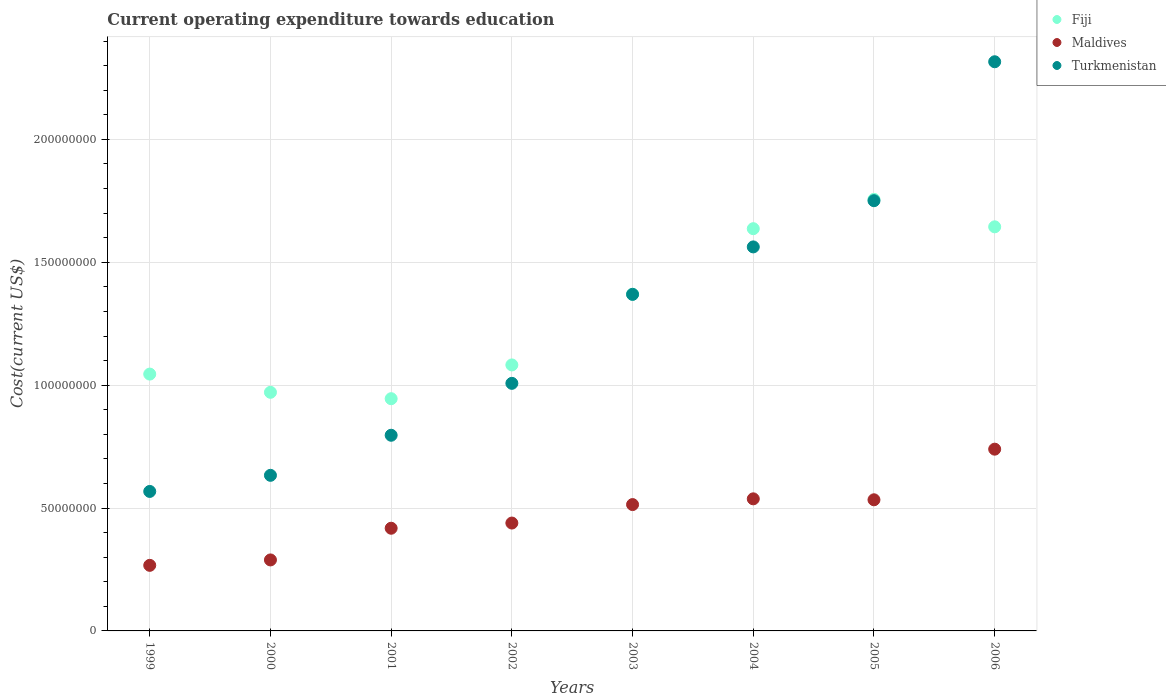How many different coloured dotlines are there?
Ensure brevity in your answer.  3. Is the number of dotlines equal to the number of legend labels?
Your answer should be compact. Yes. What is the expenditure towards education in Maldives in 2006?
Your response must be concise. 7.40e+07. Across all years, what is the maximum expenditure towards education in Turkmenistan?
Offer a terse response. 2.32e+08. Across all years, what is the minimum expenditure towards education in Fiji?
Provide a short and direct response. 9.45e+07. In which year was the expenditure towards education in Fiji minimum?
Ensure brevity in your answer.  2001. What is the total expenditure towards education in Turkmenistan in the graph?
Offer a very short reply. 1.00e+09. What is the difference between the expenditure towards education in Maldives in 1999 and that in 2006?
Give a very brief answer. -4.73e+07. What is the difference between the expenditure towards education in Turkmenistan in 2004 and the expenditure towards education in Maldives in 2000?
Provide a short and direct response. 1.27e+08. What is the average expenditure towards education in Maldives per year?
Your response must be concise. 4.67e+07. In the year 2004, what is the difference between the expenditure towards education in Maldives and expenditure towards education in Turkmenistan?
Keep it short and to the point. -1.03e+08. In how many years, is the expenditure towards education in Fiji greater than 190000000 US$?
Make the answer very short. 0. What is the ratio of the expenditure towards education in Maldives in 1999 to that in 2001?
Your answer should be compact. 0.64. Is the expenditure towards education in Maldives in 2001 less than that in 2004?
Your answer should be very brief. Yes. What is the difference between the highest and the second highest expenditure towards education in Maldives?
Make the answer very short. 2.02e+07. What is the difference between the highest and the lowest expenditure towards education in Maldives?
Give a very brief answer. 4.73e+07. Is it the case that in every year, the sum of the expenditure towards education in Maldives and expenditure towards education in Turkmenistan  is greater than the expenditure towards education in Fiji?
Your answer should be compact. No. Is the expenditure towards education in Maldives strictly greater than the expenditure towards education in Turkmenistan over the years?
Provide a short and direct response. No. Is the expenditure towards education in Turkmenistan strictly less than the expenditure towards education in Fiji over the years?
Your answer should be compact. No. How many dotlines are there?
Offer a terse response. 3. Are the values on the major ticks of Y-axis written in scientific E-notation?
Ensure brevity in your answer.  No. Does the graph contain grids?
Ensure brevity in your answer.  Yes. Where does the legend appear in the graph?
Make the answer very short. Top right. How many legend labels are there?
Keep it short and to the point. 3. How are the legend labels stacked?
Your answer should be compact. Vertical. What is the title of the graph?
Offer a terse response. Current operating expenditure towards education. Does "Puerto Rico" appear as one of the legend labels in the graph?
Ensure brevity in your answer.  No. What is the label or title of the Y-axis?
Provide a short and direct response. Cost(current US$). What is the Cost(current US$) of Fiji in 1999?
Make the answer very short. 1.05e+08. What is the Cost(current US$) in Maldives in 1999?
Provide a succinct answer. 2.67e+07. What is the Cost(current US$) in Turkmenistan in 1999?
Offer a very short reply. 5.68e+07. What is the Cost(current US$) in Fiji in 2000?
Offer a terse response. 9.71e+07. What is the Cost(current US$) in Maldives in 2000?
Keep it short and to the point. 2.89e+07. What is the Cost(current US$) in Turkmenistan in 2000?
Keep it short and to the point. 6.33e+07. What is the Cost(current US$) of Fiji in 2001?
Give a very brief answer. 9.45e+07. What is the Cost(current US$) in Maldives in 2001?
Give a very brief answer. 4.18e+07. What is the Cost(current US$) in Turkmenistan in 2001?
Make the answer very short. 7.96e+07. What is the Cost(current US$) in Fiji in 2002?
Your answer should be very brief. 1.08e+08. What is the Cost(current US$) in Maldives in 2002?
Make the answer very short. 4.39e+07. What is the Cost(current US$) in Turkmenistan in 2002?
Provide a succinct answer. 1.01e+08. What is the Cost(current US$) in Fiji in 2003?
Give a very brief answer. 1.37e+08. What is the Cost(current US$) of Maldives in 2003?
Make the answer very short. 5.14e+07. What is the Cost(current US$) of Turkmenistan in 2003?
Your answer should be compact. 1.37e+08. What is the Cost(current US$) of Fiji in 2004?
Your answer should be compact. 1.64e+08. What is the Cost(current US$) in Maldives in 2004?
Your response must be concise. 5.37e+07. What is the Cost(current US$) in Turkmenistan in 2004?
Ensure brevity in your answer.  1.56e+08. What is the Cost(current US$) in Fiji in 2005?
Offer a terse response. 1.76e+08. What is the Cost(current US$) in Maldives in 2005?
Give a very brief answer. 5.34e+07. What is the Cost(current US$) of Turkmenistan in 2005?
Offer a very short reply. 1.75e+08. What is the Cost(current US$) of Fiji in 2006?
Your answer should be compact. 1.64e+08. What is the Cost(current US$) of Maldives in 2006?
Offer a terse response. 7.40e+07. What is the Cost(current US$) in Turkmenistan in 2006?
Make the answer very short. 2.32e+08. Across all years, what is the maximum Cost(current US$) in Fiji?
Your response must be concise. 1.76e+08. Across all years, what is the maximum Cost(current US$) of Maldives?
Provide a short and direct response. 7.40e+07. Across all years, what is the maximum Cost(current US$) in Turkmenistan?
Keep it short and to the point. 2.32e+08. Across all years, what is the minimum Cost(current US$) in Fiji?
Make the answer very short. 9.45e+07. Across all years, what is the minimum Cost(current US$) of Maldives?
Make the answer very short. 2.67e+07. Across all years, what is the minimum Cost(current US$) in Turkmenistan?
Offer a terse response. 5.68e+07. What is the total Cost(current US$) of Fiji in the graph?
Give a very brief answer. 1.05e+09. What is the total Cost(current US$) of Maldives in the graph?
Offer a very short reply. 3.74e+08. What is the total Cost(current US$) of Turkmenistan in the graph?
Give a very brief answer. 1.00e+09. What is the difference between the Cost(current US$) in Fiji in 1999 and that in 2000?
Provide a succinct answer. 7.42e+06. What is the difference between the Cost(current US$) of Maldives in 1999 and that in 2000?
Provide a succinct answer. -2.20e+06. What is the difference between the Cost(current US$) of Turkmenistan in 1999 and that in 2000?
Your answer should be compact. -6.56e+06. What is the difference between the Cost(current US$) of Fiji in 1999 and that in 2001?
Make the answer very short. 1.00e+07. What is the difference between the Cost(current US$) of Maldives in 1999 and that in 2001?
Keep it short and to the point. -1.51e+07. What is the difference between the Cost(current US$) in Turkmenistan in 1999 and that in 2001?
Your answer should be compact. -2.29e+07. What is the difference between the Cost(current US$) of Fiji in 1999 and that in 2002?
Make the answer very short. -3.73e+06. What is the difference between the Cost(current US$) in Maldives in 1999 and that in 2002?
Make the answer very short. -1.72e+07. What is the difference between the Cost(current US$) in Turkmenistan in 1999 and that in 2002?
Give a very brief answer. -4.40e+07. What is the difference between the Cost(current US$) of Fiji in 1999 and that in 2003?
Your answer should be very brief. -3.25e+07. What is the difference between the Cost(current US$) of Maldives in 1999 and that in 2003?
Provide a short and direct response. -2.47e+07. What is the difference between the Cost(current US$) in Turkmenistan in 1999 and that in 2003?
Your answer should be very brief. -8.02e+07. What is the difference between the Cost(current US$) in Fiji in 1999 and that in 2004?
Your response must be concise. -5.92e+07. What is the difference between the Cost(current US$) in Maldives in 1999 and that in 2004?
Your response must be concise. -2.71e+07. What is the difference between the Cost(current US$) of Turkmenistan in 1999 and that in 2004?
Offer a very short reply. -9.95e+07. What is the difference between the Cost(current US$) in Fiji in 1999 and that in 2005?
Offer a terse response. -7.11e+07. What is the difference between the Cost(current US$) of Maldives in 1999 and that in 2005?
Your response must be concise. -2.67e+07. What is the difference between the Cost(current US$) of Turkmenistan in 1999 and that in 2005?
Offer a very short reply. -1.18e+08. What is the difference between the Cost(current US$) of Fiji in 1999 and that in 2006?
Provide a short and direct response. -5.99e+07. What is the difference between the Cost(current US$) in Maldives in 1999 and that in 2006?
Provide a succinct answer. -4.73e+07. What is the difference between the Cost(current US$) of Turkmenistan in 1999 and that in 2006?
Your response must be concise. -1.75e+08. What is the difference between the Cost(current US$) in Fiji in 2000 and that in 2001?
Your answer should be compact. 2.60e+06. What is the difference between the Cost(current US$) of Maldives in 2000 and that in 2001?
Offer a terse response. -1.29e+07. What is the difference between the Cost(current US$) in Turkmenistan in 2000 and that in 2001?
Provide a succinct answer. -1.63e+07. What is the difference between the Cost(current US$) of Fiji in 2000 and that in 2002?
Offer a very short reply. -1.11e+07. What is the difference between the Cost(current US$) of Maldives in 2000 and that in 2002?
Your response must be concise. -1.50e+07. What is the difference between the Cost(current US$) of Turkmenistan in 2000 and that in 2002?
Your answer should be compact. -3.74e+07. What is the difference between the Cost(current US$) in Fiji in 2000 and that in 2003?
Offer a very short reply. -3.99e+07. What is the difference between the Cost(current US$) of Maldives in 2000 and that in 2003?
Offer a very short reply. -2.25e+07. What is the difference between the Cost(current US$) of Turkmenistan in 2000 and that in 2003?
Your response must be concise. -7.36e+07. What is the difference between the Cost(current US$) in Fiji in 2000 and that in 2004?
Offer a terse response. -6.66e+07. What is the difference between the Cost(current US$) of Maldives in 2000 and that in 2004?
Your response must be concise. -2.49e+07. What is the difference between the Cost(current US$) of Turkmenistan in 2000 and that in 2004?
Your answer should be very brief. -9.29e+07. What is the difference between the Cost(current US$) of Fiji in 2000 and that in 2005?
Make the answer very short. -7.85e+07. What is the difference between the Cost(current US$) of Maldives in 2000 and that in 2005?
Keep it short and to the point. -2.45e+07. What is the difference between the Cost(current US$) in Turkmenistan in 2000 and that in 2005?
Ensure brevity in your answer.  -1.12e+08. What is the difference between the Cost(current US$) of Fiji in 2000 and that in 2006?
Offer a very short reply. -6.73e+07. What is the difference between the Cost(current US$) in Maldives in 2000 and that in 2006?
Offer a very short reply. -4.51e+07. What is the difference between the Cost(current US$) in Turkmenistan in 2000 and that in 2006?
Provide a short and direct response. -1.68e+08. What is the difference between the Cost(current US$) of Fiji in 2001 and that in 2002?
Ensure brevity in your answer.  -1.37e+07. What is the difference between the Cost(current US$) in Maldives in 2001 and that in 2002?
Your response must be concise. -2.11e+06. What is the difference between the Cost(current US$) of Turkmenistan in 2001 and that in 2002?
Your response must be concise. -2.11e+07. What is the difference between the Cost(current US$) in Fiji in 2001 and that in 2003?
Ensure brevity in your answer.  -4.25e+07. What is the difference between the Cost(current US$) in Maldives in 2001 and that in 2003?
Your answer should be very brief. -9.63e+06. What is the difference between the Cost(current US$) in Turkmenistan in 2001 and that in 2003?
Provide a short and direct response. -5.73e+07. What is the difference between the Cost(current US$) of Fiji in 2001 and that in 2004?
Your response must be concise. -6.92e+07. What is the difference between the Cost(current US$) of Maldives in 2001 and that in 2004?
Your answer should be compact. -1.20e+07. What is the difference between the Cost(current US$) of Turkmenistan in 2001 and that in 2004?
Your answer should be very brief. -7.66e+07. What is the difference between the Cost(current US$) in Fiji in 2001 and that in 2005?
Keep it short and to the point. -8.11e+07. What is the difference between the Cost(current US$) of Maldives in 2001 and that in 2005?
Offer a very short reply. -1.16e+07. What is the difference between the Cost(current US$) in Turkmenistan in 2001 and that in 2005?
Your answer should be compact. -9.54e+07. What is the difference between the Cost(current US$) in Fiji in 2001 and that in 2006?
Your response must be concise. -6.99e+07. What is the difference between the Cost(current US$) of Maldives in 2001 and that in 2006?
Your response must be concise. -3.22e+07. What is the difference between the Cost(current US$) of Turkmenistan in 2001 and that in 2006?
Give a very brief answer. -1.52e+08. What is the difference between the Cost(current US$) in Fiji in 2002 and that in 2003?
Your response must be concise. -2.88e+07. What is the difference between the Cost(current US$) in Maldives in 2002 and that in 2003?
Ensure brevity in your answer.  -7.51e+06. What is the difference between the Cost(current US$) in Turkmenistan in 2002 and that in 2003?
Make the answer very short. -3.62e+07. What is the difference between the Cost(current US$) of Fiji in 2002 and that in 2004?
Offer a terse response. -5.54e+07. What is the difference between the Cost(current US$) in Maldives in 2002 and that in 2004?
Your response must be concise. -9.85e+06. What is the difference between the Cost(current US$) in Turkmenistan in 2002 and that in 2004?
Make the answer very short. -5.55e+07. What is the difference between the Cost(current US$) in Fiji in 2002 and that in 2005?
Give a very brief answer. -6.74e+07. What is the difference between the Cost(current US$) of Maldives in 2002 and that in 2005?
Your answer should be very brief. -9.46e+06. What is the difference between the Cost(current US$) of Turkmenistan in 2002 and that in 2005?
Your answer should be very brief. -7.43e+07. What is the difference between the Cost(current US$) in Fiji in 2002 and that in 2006?
Keep it short and to the point. -5.62e+07. What is the difference between the Cost(current US$) of Maldives in 2002 and that in 2006?
Your answer should be very brief. -3.01e+07. What is the difference between the Cost(current US$) of Turkmenistan in 2002 and that in 2006?
Your answer should be very brief. -1.31e+08. What is the difference between the Cost(current US$) of Fiji in 2003 and that in 2004?
Your answer should be compact. -2.67e+07. What is the difference between the Cost(current US$) of Maldives in 2003 and that in 2004?
Give a very brief answer. -2.34e+06. What is the difference between the Cost(current US$) of Turkmenistan in 2003 and that in 2004?
Give a very brief answer. -1.93e+07. What is the difference between the Cost(current US$) of Fiji in 2003 and that in 2005?
Provide a succinct answer. -3.86e+07. What is the difference between the Cost(current US$) of Maldives in 2003 and that in 2005?
Make the answer very short. -1.95e+06. What is the difference between the Cost(current US$) in Turkmenistan in 2003 and that in 2005?
Your answer should be compact. -3.81e+07. What is the difference between the Cost(current US$) in Fiji in 2003 and that in 2006?
Provide a short and direct response. -2.74e+07. What is the difference between the Cost(current US$) in Maldives in 2003 and that in 2006?
Your answer should be compact. -2.25e+07. What is the difference between the Cost(current US$) in Turkmenistan in 2003 and that in 2006?
Give a very brief answer. -9.46e+07. What is the difference between the Cost(current US$) in Fiji in 2004 and that in 2005?
Your answer should be compact. -1.19e+07. What is the difference between the Cost(current US$) in Maldives in 2004 and that in 2005?
Make the answer very short. 3.88e+05. What is the difference between the Cost(current US$) of Turkmenistan in 2004 and that in 2005?
Your answer should be compact. -1.88e+07. What is the difference between the Cost(current US$) of Fiji in 2004 and that in 2006?
Give a very brief answer. -7.61e+05. What is the difference between the Cost(current US$) in Maldives in 2004 and that in 2006?
Ensure brevity in your answer.  -2.02e+07. What is the difference between the Cost(current US$) of Turkmenistan in 2004 and that in 2006?
Your answer should be very brief. -7.53e+07. What is the difference between the Cost(current US$) in Fiji in 2005 and that in 2006?
Offer a very short reply. 1.12e+07. What is the difference between the Cost(current US$) in Maldives in 2005 and that in 2006?
Provide a short and direct response. -2.06e+07. What is the difference between the Cost(current US$) in Turkmenistan in 2005 and that in 2006?
Provide a short and direct response. -5.65e+07. What is the difference between the Cost(current US$) in Fiji in 1999 and the Cost(current US$) in Maldives in 2000?
Provide a succinct answer. 7.56e+07. What is the difference between the Cost(current US$) of Fiji in 1999 and the Cost(current US$) of Turkmenistan in 2000?
Provide a short and direct response. 4.12e+07. What is the difference between the Cost(current US$) in Maldives in 1999 and the Cost(current US$) in Turkmenistan in 2000?
Offer a very short reply. -3.66e+07. What is the difference between the Cost(current US$) in Fiji in 1999 and the Cost(current US$) in Maldives in 2001?
Keep it short and to the point. 6.27e+07. What is the difference between the Cost(current US$) in Fiji in 1999 and the Cost(current US$) in Turkmenistan in 2001?
Make the answer very short. 2.49e+07. What is the difference between the Cost(current US$) in Maldives in 1999 and the Cost(current US$) in Turkmenistan in 2001?
Make the answer very short. -5.29e+07. What is the difference between the Cost(current US$) in Fiji in 1999 and the Cost(current US$) in Maldives in 2002?
Provide a succinct answer. 6.06e+07. What is the difference between the Cost(current US$) in Fiji in 1999 and the Cost(current US$) in Turkmenistan in 2002?
Provide a succinct answer. 3.77e+06. What is the difference between the Cost(current US$) of Maldives in 1999 and the Cost(current US$) of Turkmenistan in 2002?
Offer a very short reply. -7.41e+07. What is the difference between the Cost(current US$) in Fiji in 1999 and the Cost(current US$) in Maldives in 2003?
Provide a succinct answer. 5.31e+07. What is the difference between the Cost(current US$) in Fiji in 1999 and the Cost(current US$) in Turkmenistan in 2003?
Offer a very short reply. -3.24e+07. What is the difference between the Cost(current US$) in Maldives in 1999 and the Cost(current US$) in Turkmenistan in 2003?
Your answer should be compact. -1.10e+08. What is the difference between the Cost(current US$) in Fiji in 1999 and the Cost(current US$) in Maldives in 2004?
Make the answer very short. 5.08e+07. What is the difference between the Cost(current US$) in Fiji in 1999 and the Cost(current US$) in Turkmenistan in 2004?
Your answer should be compact. -5.17e+07. What is the difference between the Cost(current US$) of Maldives in 1999 and the Cost(current US$) of Turkmenistan in 2004?
Make the answer very short. -1.30e+08. What is the difference between the Cost(current US$) of Fiji in 1999 and the Cost(current US$) of Maldives in 2005?
Provide a succinct answer. 5.11e+07. What is the difference between the Cost(current US$) of Fiji in 1999 and the Cost(current US$) of Turkmenistan in 2005?
Keep it short and to the point. -7.06e+07. What is the difference between the Cost(current US$) in Maldives in 1999 and the Cost(current US$) in Turkmenistan in 2005?
Ensure brevity in your answer.  -1.48e+08. What is the difference between the Cost(current US$) in Fiji in 1999 and the Cost(current US$) in Maldives in 2006?
Your answer should be compact. 3.06e+07. What is the difference between the Cost(current US$) of Fiji in 1999 and the Cost(current US$) of Turkmenistan in 2006?
Keep it short and to the point. -1.27e+08. What is the difference between the Cost(current US$) in Maldives in 1999 and the Cost(current US$) in Turkmenistan in 2006?
Give a very brief answer. -2.05e+08. What is the difference between the Cost(current US$) in Fiji in 2000 and the Cost(current US$) in Maldives in 2001?
Offer a very short reply. 5.53e+07. What is the difference between the Cost(current US$) of Fiji in 2000 and the Cost(current US$) of Turkmenistan in 2001?
Provide a short and direct response. 1.75e+07. What is the difference between the Cost(current US$) of Maldives in 2000 and the Cost(current US$) of Turkmenistan in 2001?
Provide a short and direct response. -5.07e+07. What is the difference between the Cost(current US$) of Fiji in 2000 and the Cost(current US$) of Maldives in 2002?
Give a very brief answer. 5.32e+07. What is the difference between the Cost(current US$) in Fiji in 2000 and the Cost(current US$) in Turkmenistan in 2002?
Offer a very short reply. -3.65e+06. What is the difference between the Cost(current US$) of Maldives in 2000 and the Cost(current US$) of Turkmenistan in 2002?
Your answer should be very brief. -7.19e+07. What is the difference between the Cost(current US$) in Fiji in 2000 and the Cost(current US$) in Maldives in 2003?
Make the answer very short. 4.57e+07. What is the difference between the Cost(current US$) of Fiji in 2000 and the Cost(current US$) of Turkmenistan in 2003?
Provide a short and direct response. -3.99e+07. What is the difference between the Cost(current US$) in Maldives in 2000 and the Cost(current US$) in Turkmenistan in 2003?
Offer a very short reply. -1.08e+08. What is the difference between the Cost(current US$) in Fiji in 2000 and the Cost(current US$) in Maldives in 2004?
Give a very brief answer. 4.33e+07. What is the difference between the Cost(current US$) of Fiji in 2000 and the Cost(current US$) of Turkmenistan in 2004?
Offer a terse response. -5.92e+07. What is the difference between the Cost(current US$) of Maldives in 2000 and the Cost(current US$) of Turkmenistan in 2004?
Offer a very short reply. -1.27e+08. What is the difference between the Cost(current US$) in Fiji in 2000 and the Cost(current US$) in Maldives in 2005?
Your answer should be very brief. 4.37e+07. What is the difference between the Cost(current US$) of Fiji in 2000 and the Cost(current US$) of Turkmenistan in 2005?
Your answer should be compact. -7.80e+07. What is the difference between the Cost(current US$) in Maldives in 2000 and the Cost(current US$) in Turkmenistan in 2005?
Give a very brief answer. -1.46e+08. What is the difference between the Cost(current US$) of Fiji in 2000 and the Cost(current US$) of Maldives in 2006?
Give a very brief answer. 2.31e+07. What is the difference between the Cost(current US$) in Fiji in 2000 and the Cost(current US$) in Turkmenistan in 2006?
Your answer should be very brief. -1.35e+08. What is the difference between the Cost(current US$) in Maldives in 2000 and the Cost(current US$) in Turkmenistan in 2006?
Provide a short and direct response. -2.03e+08. What is the difference between the Cost(current US$) in Fiji in 2001 and the Cost(current US$) in Maldives in 2002?
Keep it short and to the point. 5.06e+07. What is the difference between the Cost(current US$) of Fiji in 2001 and the Cost(current US$) of Turkmenistan in 2002?
Make the answer very short. -6.25e+06. What is the difference between the Cost(current US$) in Maldives in 2001 and the Cost(current US$) in Turkmenistan in 2002?
Provide a succinct answer. -5.90e+07. What is the difference between the Cost(current US$) of Fiji in 2001 and the Cost(current US$) of Maldives in 2003?
Offer a terse response. 4.31e+07. What is the difference between the Cost(current US$) in Fiji in 2001 and the Cost(current US$) in Turkmenistan in 2003?
Provide a succinct answer. -4.25e+07. What is the difference between the Cost(current US$) of Maldives in 2001 and the Cost(current US$) of Turkmenistan in 2003?
Offer a very short reply. -9.52e+07. What is the difference between the Cost(current US$) of Fiji in 2001 and the Cost(current US$) of Maldives in 2004?
Ensure brevity in your answer.  4.07e+07. What is the difference between the Cost(current US$) in Fiji in 2001 and the Cost(current US$) in Turkmenistan in 2004?
Offer a very short reply. -6.18e+07. What is the difference between the Cost(current US$) in Maldives in 2001 and the Cost(current US$) in Turkmenistan in 2004?
Offer a terse response. -1.14e+08. What is the difference between the Cost(current US$) in Fiji in 2001 and the Cost(current US$) in Maldives in 2005?
Keep it short and to the point. 4.11e+07. What is the difference between the Cost(current US$) of Fiji in 2001 and the Cost(current US$) of Turkmenistan in 2005?
Ensure brevity in your answer.  -8.06e+07. What is the difference between the Cost(current US$) in Maldives in 2001 and the Cost(current US$) in Turkmenistan in 2005?
Ensure brevity in your answer.  -1.33e+08. What is the difference between the Cost(current US$) in Fiji in 2001 and the Cost(current US$) in Maldives in 2006?
Your response must be concise. 2.05e+07. What is the difference between the Cost(current US$) of Fiji in 2001 and the Cost(current US$) of Turkmenistan in 2006?
Provide a succinct answer. -1.37e+08. What is the difference between the Cost(current US$) in Maldives in 2001 and the Cost(current US$) in Turkmenistan in 2006?
Offer a terse response. -1.90e+08. What is the difference between the Cost(current US$) of Fiji in 2002 and the Cost(current US$) of Maldives in 2003?
Your answer should be compact. 5.68e+07. What is the difference between the Cost(current US$) in Fiji in 2002 and the Cost(current US$) in Turkmenistan in 2003?
Make the answer very short. -2.87e+07. What is the difference between the Cost(current US$) in Maldives in 2002 and the Cost(current US$) in Turkmenistan in 2003?
Make the answer very short. -9.30e+07. What is the difference between the Cost(current US$) of Fiji in 2002 and the Cost(current US$) of Maldives in 2004?
Keep it short and to the point. 5.45e+07. What is the difference between the Cost(current US$) of Fiji in 2002 and the Cost(current US$) of Turkmenistan in 2004?
Give a very brief answer. -4.80e+07. What is the difference between the Cost(current US$) of Maldives in 2002 and the Cost(current US$) of Turkmenistan in 2004?
Provide a succinct answer. -1.12e+08. What is the difference between the Cost(current US$) of Fiji in 2002 and the Cost(current US$) of Maldives in 2005?
Offer a terse response. 5.49e+07. What is the difference between the Cost(current US$) of Fiji in 2002 and the Cost(current US$) of Turkmenistan in 2005?
Ensure brevity in your answer.  -6.68e+07. What is the difference between the Cost(current US$) of Maldives in 2002 and the Cost(current US$) of Turkmenistan in 2005?
Keep it short and to the point. -1.31e+08. What is the difference between the Cost(current US$) in Fiji in 2002 and the Cost(current US$) in Maldives in 2006?
Offer a very short reply. 3.43e+07. What is the difference between the Cost(current US$) in Fiji in 2002 and the Cost(current US$) in Turkmenistan in 2006?
Your response must be concise. -1.23e+08. What is the difference between the Cost(current US$) in Maldives in 2002 and the Cost(current US$) in Turkmenistan in 2006?
Provide a short and direct response. -1.88e+08. What is the difference between the Cost(current US$) of Fiji in 2003 and the Cost(current US$) of Maldives in 2004?
Provide a short and direct response. 8.33e+07. What is the difference between the Cost(current US$) in Fiji in 2003 and the Cost(current US$) in Turkmenistan in 2004?
Give a very brief answer. -1.92e+07. What is the difference between the Cost(current US$) of Maldives in 2003 and the Cost(current US$) of Turkmenistan in 2004?
Offer a terse response. -1.05e+08. What is the difference between the Cost(current US$) in Fiji in 2003 and the Cost(current US$) in Maldives in 2005?
Make the answer very short. 8.37e+07. What is the difference between the Cost(current US$) in Fiji in 2003 and the Cost(current US$) in Turkmenistan in 2005?
Offer a terse response. -3.80e+07. What is the difference between the Cost(current US$) of Maldives in 2003 and the Cost(current US$) of Turkmenistan in 2005?
Provide a short and direct response. -1.24e+08. What is the difference between the Cost(current US$) in Fiji in 2003 and the Cost(current US$) in Maldives in 2006?
Provide a short and direct response. 6.31e+07. What is the difference between the Cost(current US$) of Fiji in 2003 and the Cost(current US$) of Turkmenistan in 2006?
Ensure brevity in your answer.  -9.46e+07. What is the difference between the Cost(current US$) in Maldives in 2003 and the Cost(current US$) in Turkmenistan in 2006?
Your answer should be very brief. -1.80e+08. What is the difference between the Cost(current US$) in Fiji in 2004 and the Cost(current US$) in Maldives in 2005?
Keep it short and to the point. 1.10e+08. What is the difference between the Cost(current US$) in Fiji in 2004 and the Cost(current US$) in Turkmenistan in 2005?
Give a very brief answer. -1.14e+07. What is the difference between the Cost(current US$) in Maldives in 2004 and the Cost(current US$) in Turkmenistan in 2005?
Provide a succinct answer. -1.21e+08. What is the difference between the Cost(current US$) in Fiji in 2004 and the Cost(current US$) in Maldives in 2006?
Provide a succinct answer. 8.97e+07. What is the difference between the Cost(current US$) in Fiji in 2004 and the Cost(current US$) in Turkmenistan in 2006?
Make the answer very short. -6.79e+07. What is the difference between the Cost(current US$) of Maldives in 2004 and the Cost(current US$) of Turkmenistan in 2006?
Your answer should be very brief. -1.78e+08. What is the difference between the Cost(current US$) of Fiji in 2005 and the Cost(current US$) of Maldives in 2006?
Provide a succinct answer. 1.02e+08. What is the difference between the Cost(current US$) of Fiji in 2005 and the Cost(current US$) of Turkmenistan in 2006?
Provide a succinct answer. -5.60e+07. What is the difference between the Cost(current US$) of Maldives in 2005 and the Cost(current US$) of Turkmenistan in 2006?
Your answer should be compact. -1.78e+08. What is the average Cost(current US$) of Fiji per year?
Offer a terse response. 1.31e+08. What is the average Cost(current US$) in Maldives per year?
Provide a succinct answer. 4.67e+07. What is the average Cost(current US$) of Turkmenistan per year?
Offer a very short reply. 1.25e+08. In the year 1999, what is the difference between the Cost(current US$) in Fiji and Cost(current US$) in Maldives?
Make the answer very short. 7.78e+07. In the year 1999, what is the difference between the Cost(current US$) of Fiji and Cost(current US$) of Turkmenistan?
Provide a succinct answer. 4.78e+07. In the year 1999, what is the difference between the Cost(current US$) in Maldives and Cost(current US$) in Turkmenistan?
Give a very brief answer. -3.01e+07. In the year 2000, what is the difference between the Cost(current US$) of Fiji and Cost(current US$) of Maldives?
Offer a terse response. 6.82e+07. In the year 2000, what is the difference between the Cost(current US$) in Fiji and Cost(current US$) in Turkmenistan?
Offer a very short reply. 3.38e+07. In the year 2000, what is the difference between the Cost(current US$) in Maldives and Cost(current US$) in Turkmenistan?
Offer a terse response. -3.44e+07. In the year 2001, what is the difference between the Cost(current US$) of Fiji and Cost(current US$) of Maldives?
Provide a short and direct response. 5.27e+07. In the year 2001, what is the difference between the Cost(current US$) in Fiji and Cost(current US$) in Turkmenistan?
Make the answer very short. 1.49e+07. In the year 2001, what is the difference between the Cost(current US$) in Maldives and Cost(current US$) in Turkmenistan?
Offer a terse response. -3.78e+07. In the year 2002, what is the difference between the Cost(current US$) in Fiji and Cost(current US$) in Maldives?
Provide a succinct answer. 6.43e+07. In the year 2002, what is the difference between the Cost(current US$) in Fiji and Cost(current US$) in Turkmenistan?
Provide a succinct answer. 7.49e+06. In the year 2002, what is the difference between the Cost(current US$) in Maldives and Cost(current US$) in Turkmenistan?
Provide a succinct answer. -5.68e+07. In the year 2003, what is the difference between the Cost(current US$) of Fiji and Cost(current US$) of Maldives?
Ensure brevity in your answer.  8.56e+07. In the year 2003, what is the difference between the Cost(current US$) in Fiji and Cost(current US$) in Turkmenistan?
Provide a short and direct response. 6.57e+04. In the year 2003, what is the difference between the Cost(current US$) in Maldives and Cost(current US$) in Turkmenistan?
Offer a very short reply. -8.55e+07. In the year 2004, what is the difference between the Cost(current US$) in Fiji and Cost(current US$) in Maldives?
Your answer should be compact. 1.10e+08. In the year 2004, what is the difference between the Cost(current US$) in Fiji and Cost(current US$) in Turkmenistan?
Make the answer very short. 7.41e+06. In the year 2004, what is the difference between the Cost(current US$) in Maldives and Cost(current US$) in Turkmenistan?
Your answer should be compact. -1.03e+08. In the year 2005, what is the difference between the Cost(current US$) in Fiji and Cost(current US$) in Maldives?
Make the answer very short. 1.22e+08. In the year 2005, what is the difference between the Cost(current US$) of Fiji and Cost(current US$) of Turkmenistan?
Make the answer very short. 5.44e+05. In the year 2005, what is the difference between the Cost(current US$) in Maldives and Cost(current US$) in Turkmenistan?
Keep it short and to the point. -1.22e+08. In the year 2006, what is the difference between the Cost(current US$) in Fiji and Cost(current US$) in Maldives?
Give a very brief answer. 9.05e+07. In the year 2006, what is the difference between the Cost(current US$) of Fiji and Cost(current US$) of Turkmenistan?
Your answer should be compact. -6.72e+07. In the year 2006, what is the difference between the Cost(current US$) of Maldives and Cost(current US$) of Turkmenistan?
Your response must be concise. -1.58e+08. What is the ratio of the Cost(current US$) of Fiji in 1999 to that in 2000?
Provide a short and direct response. 1.08. What is the ratio of the Cost(current US$) of Maldives in 1999 to that in 2000?
Provide a succinct answer. 0.92. What is the ratio of the Cost(current US$) in Turkmenistan in 1999 to that in 2000?
Your answer should be very brief. 0.9. What is the ratio of the Cost(current US$) in Fiji in 1999 to that in 2001?
Offer a terse response. 1.11. What is the ratio of the Cost(current US$) of Maldives in 1999 to that in 2001?
Your answer should be compact. 0.64. What is the ratio of the Cost(current US$) in Turkmenistan in 1999 to that in 2001?
Keep it short and to the point. 0.71. What is the ratio of the Cost(current US$) in Fiji in 1999 to that in 2002?
Offer a very short reply. 0.97. What is the ratio of the Cost(current US$) in Maldives in 1999 to that in 2002?
Offer a very short reply. 0.61. What is the ratio of the Cost(current US$) in Turkmenistan in 1999 to that in 2002?
Your response must be concise. 0.56. What is the ratio of the Cost(current US$) in Fiji in 1999 to that in 2003?
Your response must be concise. 0.76. What is the ratio of the Cost(current US$) in Maldives in 1999 to that in 2003?
Your response must be concise. 0.52. What is the ratio of the Cost(current US$) of Turkmenistan in 1999 to that in 2003?
Your answer should be compact. 0.41. What is the ratio of the Cost(current US$) of Fiji in 1999 to that in 2004?
Keep it short and to the point. 0.64. What is the ratio of the Cost(current US$) of Maldives in 1999 to that in 2004?
Offer a terse response. 0.5. What is the ratio of the Cost(current US$) of Turkmenistan in 1999 to that in 2004?
Keep it short and to the point. 0.36. What is the ratio of the Cost(current US$) of Fiji in 1999 to that in 2005?
Provide a succinct answer. 0.6. What is the ratio of the Cost(current US$) of Maldives in 1999 to that in 2005?
Your answer should be very brief. 0.5. What is the ratio of the Cost(current US$) in Turkmenistan in 1999 to that in 2005?
Offer a terse response. 0.32. What is the ratio of the Cost(current US$) in Fiji in 1999 to that in 2006?
Ensure brevity in your answer.  0.64. What is the ratio of the Cost(current US$) in Maldives in 1999 to that in 2006?
Ensure brevity in your answer.  0.36. What is the ratio of the Cost(current US$) in Turkmenistan in 1999 to that in 2006?
Your answer should be compact. 0.25. What is the ratio of the Cost(current US$) in Fiji in 2000 to that in 2001?
Your response must be concise. 1.03. What is the ratio of the Cost(current US$) of Maldives in 2000 to that in 2001?
Your answer should be very brief. 0.69. What is the ratio of the Cost(current US$) of Turkmenistan in 2000 to that in 2001?
Offer a very short reply. 0.8. What is the ratio of the Cost(current US$) of Fiji in 2000 to that in 2002?
Offer a very short reply. 0.9. What is the ratio of the Cost(current US$) in Maldives in 2000 to that in 2002?
Give a very brief answer. 0.66. What is the ratio of the Cost(current US$) in Turkmenistan in 2000 to that in 2002?
Your response must be concise. 0.63. What is the ratio of the Cost(current US$) of Fiji in 2000 to that in 2003?
Give a very brief answer. 0.71. What is the ratio of the Cost(current US$) of Maldives in 2000 to that in 2003?
Your answer should be compact. 0.56. What is the ratio of the Cost(current US$) in Turkmenistan in 2000 to that in 2003?
Make the answer very short. 0.46. What is the ratio of the Cost(current US$) in Fiji in 2000 to that in 2004?
Give a very brief answer. 0.59. What is the ratio of the Cost(current US$) in Maldives in 2000 to that in 2004?
Offer a terse response. 0.54. What is the ratio of the Cost(current US$) in Turkmenistan in 2000 to that in 2004?
Your answer should be very brief. 0.41. What is the ratio of the Cost(current US$) of Fiji in 2000 to that in 2005?
Your answer should be compact. 0.55. What is the ratio of the Cost(current US$) in Maldives in 2000 to that in 2005?
Ensure brevity in your answer.  0.54. What is the ratio of the Cost(current US$) of Turkmenistan in 2000 to that in 2005?
Your answer should be compact. 0.36. What is the ratio of the Cost(current US$) of Fiji in 2000 to that in 2006?
Your response must be concise. 0.59. What is the ratio of the Cost(current US$) in Maldives in 2000 to that in 2006?
Provide a succinct answer. 0.39. What is the ratio of the Cost(current US$) in Turkmenistan in 2000 to that in 2006?
Your answer should be compact. 0.27. What is the ratio of the Cost(current US$) of Fiji in 2001 to that in 2002?
Provide a succinct answer. 0.87. What is the ratio of the Cost(current US$) of Maldives in 2001 to that in 2002?
Offer a terse response. 0.95. What is the ratio of the Cost(current US$) of Turkmenistan in 2001 to that in 2002?
Your answer should be very brief. 0.79. What is the ratio of the Cost(current US$) in Fiji in 2001 to that in 2003?
Ensure brevity in your answer.  0.69. What is the ratio of the Cost(current US$) of Maldives in 2001 to that in 2003?
Offer a very short reply. 0.81. What is the ratio of the Cost(current US$) of Turkmenistan in 2001 to that in 2003?
Give a very brief answer. 0.58. What is the ratio of the Cost(current US$) in Fiji in 2001 to that in 2004?
Make the answer very short. 0.58. What is the ratio of the Cost(current US$) of Maldives in 2001 to that in 2004?
Your answer should be very brief. 0.78. What is the ratio of the Cost(current US$) in Turkmenistan in 2001 to that in 2004?
Your response must be concise. 0.51. What is the ratio of the Cost(current US$) in Fiji in 2001 to that in 2005?
Make the answer very short. 0.54. What is the ratio of the Cost(current US$) in Maldives in 2001 to that in 2005?
Your answer should be very brief. 0.78. What is the ratio of the Cost(current US$) of Turkmenistan in 2001 to that in 2005?
Provide a succinct answer. 0.45. What is the ratio of the Cost(current US$) of Fiji in 2001 to that in 2006?
Keep it short and to the point. 0.57. What is the ratio of the Cost(current US$) of Maldives in 2001 to that in 2006?
Ensure brevity in your answer.  0.56. What is the ratio of the Cost(current US$) of Turkmenistan in 2001 to that in 2006?
Offer a very short reply. 0.34. What is the ratio of the Cost(current US$) of Fiji in 2002 to that in 2003?
Your answer should be very brief. 0.79. What is the ratio of the Cost(current US$) in Maldives in 2002 to that in 2003?
Offer a very short reply. 0.85. What is the ratio of the Cost(current US$) of Turkmenistan in 2002 to that in 2003?
Your answer should be compact. 0.74. What is the ratio of the Cost(current US$) in Fiji in 2002 to that in 2004?
Keep it short and to the point. 0.66. What is the ratio of the Cost(current US$) of Maldives in 2002 to that in 2004?
Give a very brief answer. 0.82. What is the ratio of the Cost(current US$) of Turkmenistan in 2002 to that in 2004?
Offer a very short reply. 0.64. What is the ratio of the Cost(current US$) in Fiji in 2002 to that in 2005?
Your response must be concise. 0.62. What is the ratio of the Cost(current US$) of Maldives in 2002 to that in 2005?
Offer a very short reply. 0.82. What is the ratio of the Cost(current US$) in Turkmenistan in 2002 to that in 2005?
Give a very brief answer. 0.58. What is the ratio of the Cost(current US$) of Fiji in 2002 to that in 2006?
Your response must be concise. 0.66. What is the ratio of the Cost(current US$) in Maldives in 2002 to that in 2006?
Your response must be concise. 0.59. What is the ratio of the Cost(current US$) in Turkmenistan in 2002 to that in 2006?
Give a very brief answer. 0.43. What is the ratio of the Cost(current US$) of Fiji in 2003 to that in 2004?
Make the answer very short. 0.84. What is the ratio of the Cost(current US$) of Maldives in 2003 to that in 2004?
Make the answer very short. 0.96. What is the ratio of the Cost(current US$) of Turkmenistan in 2003 to that in 2004?
Provide a succinct answer. 0.88. What is the ratio of the Cost(current US$) of Fiji in 2003 to that in 2005?
Offer a very short reply. 0.78. What is the ratio of the Cost(current US$) of Maldives in 2003 to that in 2005?
Give a very brief answer. 0.96. What is the ratio of the Cost(current US$) of Turkmenistan in 2003 to that in 2005?
Ensure brevity in your answer.  0.78. What is the ratio of the Cost(current US$) of Fiji in 2003 to that in 2006?
Give a very brief answer. 0.83. What is the ratio of the Cost(current US$) of Maldives in 2003 to that in 2006?
Offer a very short reply. 0.7. What is the ratio of the Cost(current US$) in Turkmenistan in 2003 to that in 2006?
Provide a succinct answer. 0.59. What is the ratio of the Cost(current US$) in Fiji in 2004 to that in 2005?
Your answer should be very brief. 0.93. What is the ratio of the Cost(current US$) in Maldives in 2004 to that in 2005?
Provide a succinct answer. 1.01. What is the ratio of the Cost(current US$) of Turkmenistan in 2004 to that in 2005?
Keep it short and to the point. 0.89. What is the ratio of the Cost(current US$) in Maldives in 2004 to that in 2006?
Your response must be concise. 0.73. What is the ratio of the Cost(current US$) of Turkmenistan in 2004 to that in 2006?
Provide a short and direct response. 0.67. What is the ratio of the Cost(current US$) of Fiji in 2005 to that in 2006?
Your answer should be very brief. 1.07. What is the ratio of the Cost(current US$) in Maldives in 2005 to that in 2006?
Keep it short and to the point. 0.72. What is the ratio of the Cost(current US$) of Turkmenistan in 2005 to that in 2006?
Provide a short and direct response. 0.76. What is the difference between the highest and the second highest Cost(current US$) of Fiji?
Your answer should be compact. 1.12e+07. What is the difference between the highest and the second highest Cost(current US$) of Maldives?
Ensure brevity in your answer.  2.02e+07. What is the difference between the highest and the second highest Cost(current US$) of Turkmenistan?
Your answer should be compact. 5.65e+07. What is the difference between the highest and the lowest Cost(current US$) in Fiji?
Provide a short and direct response. 8.11e+07. What is the difference between the highest and the lowest Cost(current US$) of Maldives?
Your answer should be very brief. 4.73e+07. What is the difference between the highest and the lowest Cost(current US$) in Turkmenistan?
Offer a very short reply. 1.75e+08. 